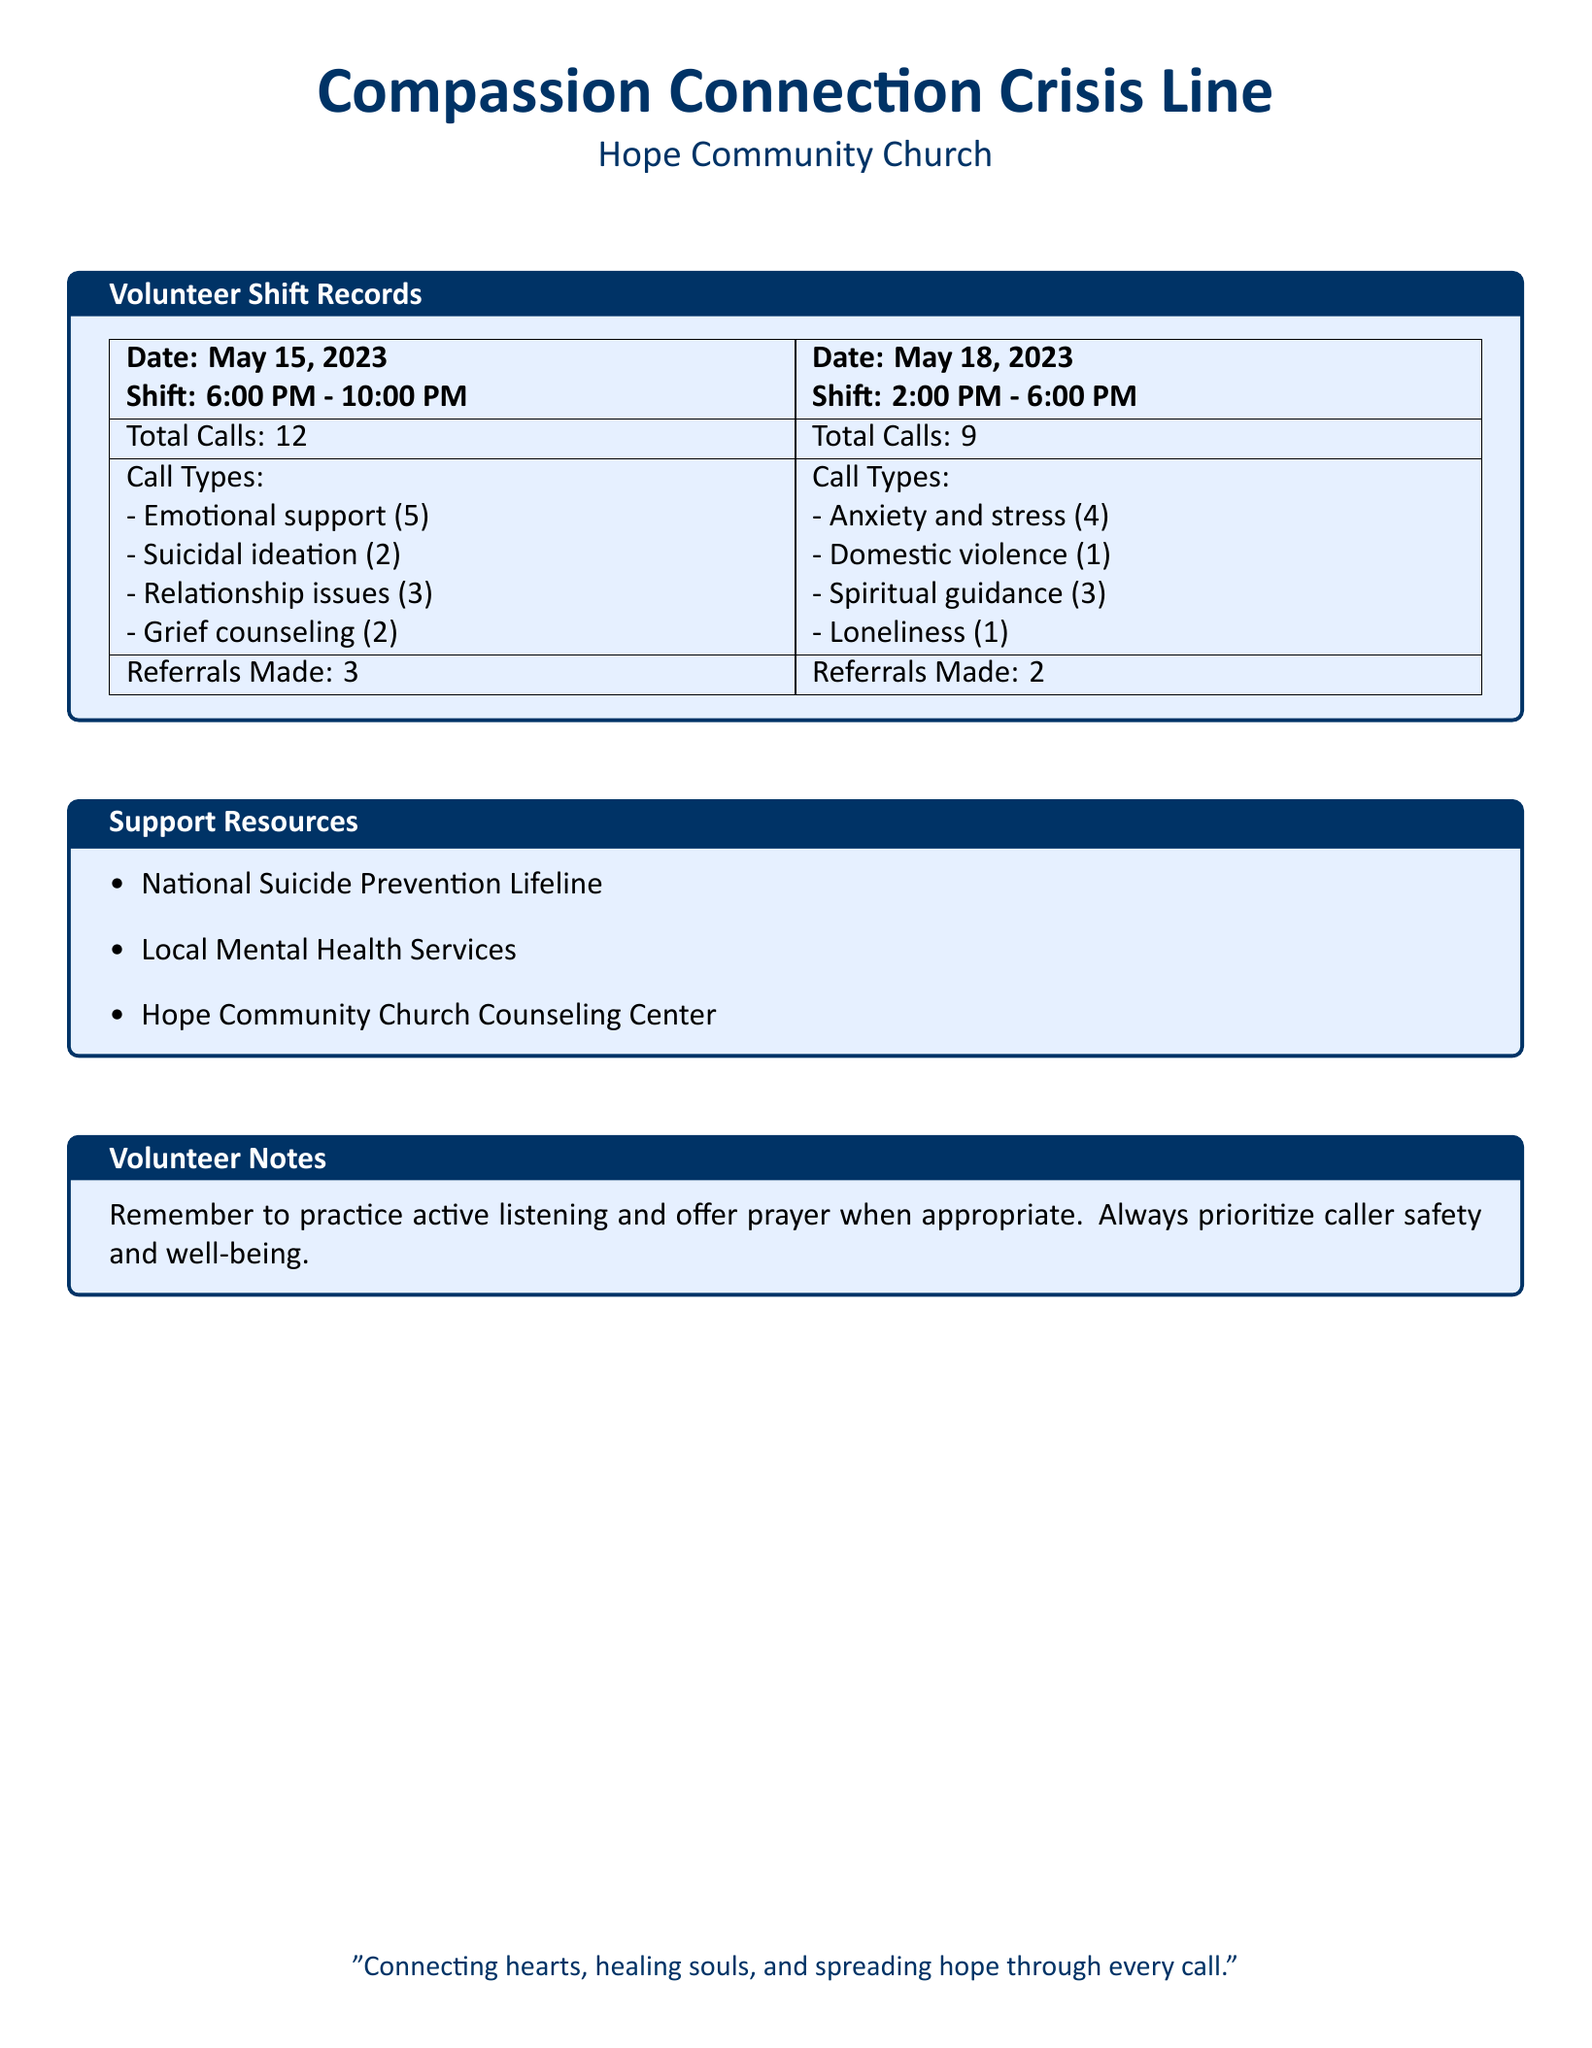What is the total number of calls on May 15, 2023? The total number of calls is provided under the "Total Calls" section for May 15, 2023, which states there were 12 calls.
Answer: 12 What types of support were provided during the shift on May 18, 2023? The types of support are listed under "Call Types" for May 18, 2023, detailing various issues like anxiety, domestic violence, and spiritual guidance.
Answer: Anxiety and stress, Domestic violence, Spiritual guidance, Loneliness How many referrals were made on May 15, 2023? The number of referrals made is located under the "Referrals Made" section for May 15, 2023, which indicates that 3 referrals were made.
Answer: 3 Which organization provides grief counseling? The support resources detail various organizations, including the Hope Community Church Counseling Center, which may offer grief counseling.
Answer: Hope Community Church Counseling Center What is the shift time for May 18, 2023? The shift times are noted at the top of each record, and for May 18, 2023, the shift time is from 2:00 PM to 6:00 PM.
Answer: 2:00 PM - 6:00 PM How many total calls were recorded on May 18, 2023? The total calls are also indicated in the document under the "Total Calls" section for May 18, 2023, which states there were 9 calls.
Answer: 9 What is the main purpose of the Compassion Connection Crisis Line? The main purpose can be inferred from the motto at the bottom of the document, emphasizing connection and healing through calls.
Answer: Connecting hearts, healing souls, and spreading hope through every call What should volunteers prioritize while taking calls? There is a note in the "Volunteer Notes" section that specifies the priorities of volunteers while interacting with callers.
Answer: Caller safety and well-being 